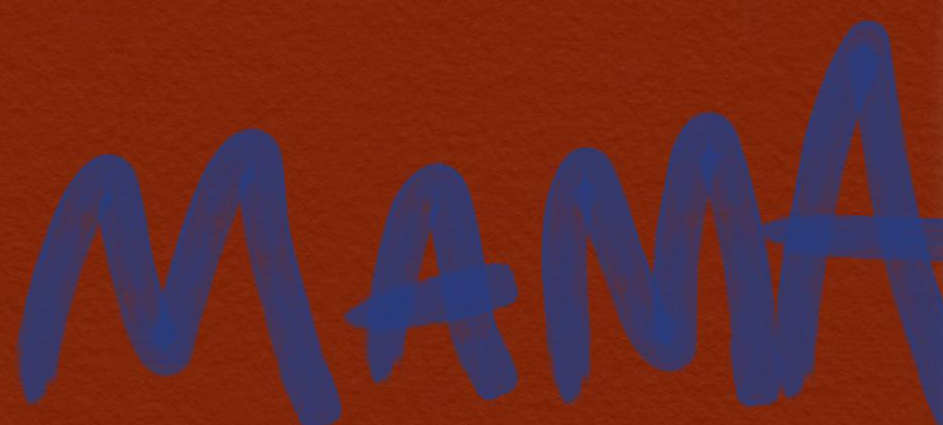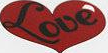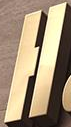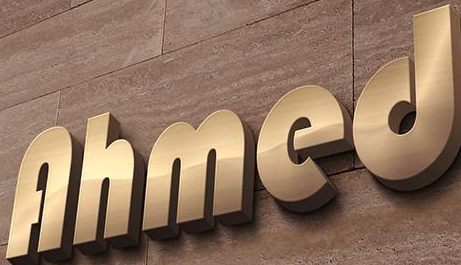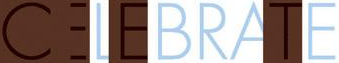Identify the words shown in these images in order, separated by a semicolon. MAMA; Love; H; Ahmed; CELEBRATE 